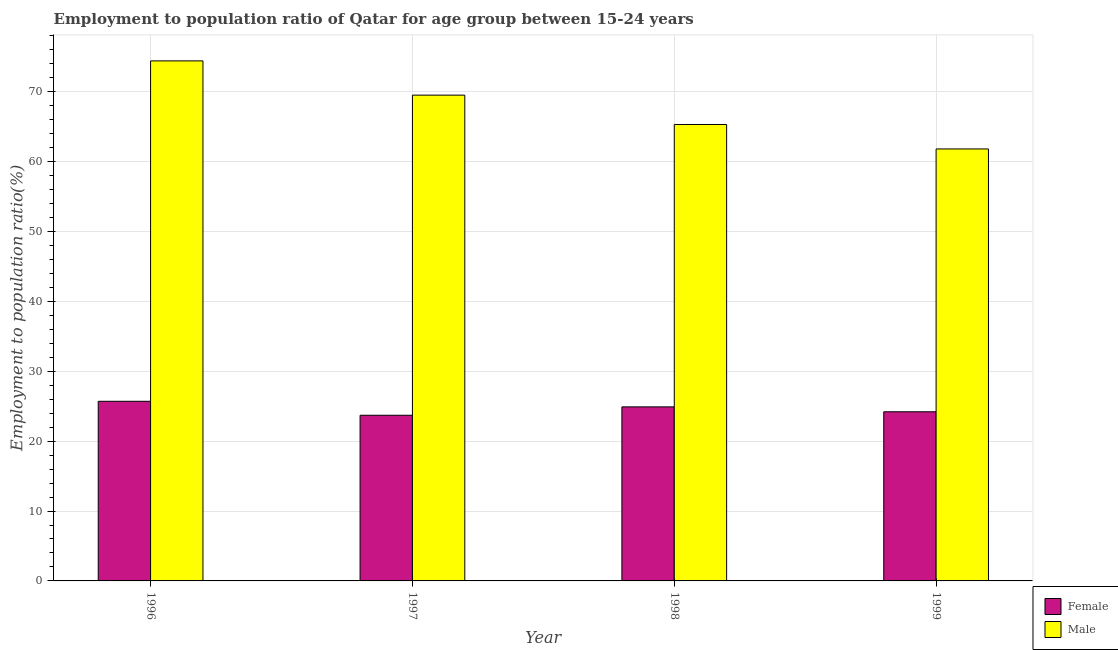How many different coloured bars are there?
Offer a very short reply. 2. Are the number of bars on each tick of the X-axis equal?
Your answer should be compact. Yes. How many bars are there on the 2nd tick from the right?
Offer a terse response. 2. What is the label of the 1st group of bars from the left?
Your answer should be compact. 1996. In how many cases, is the number of bars for a given year not equal to the number of legend labels?
Provide a short and direct response. 0. What is the employment to population ratio(female) in 1999?
Offer a very short reply. 24.2. Across all years, what is the maximum employment to population ratio(male)?
Give a very brief answer. 74.4. Across all years, what is the minimum employment to population ratio(male)?
Keep it short and to the point. 61.8. In which year was the employment to population ratio(female) maximum?
Your answer should be compact. 1996. In which year was the employment to population ratio(female) minimum?
Ensure brevity in your answer.  1997. What is the total employment to population ratio(male) in the graph?
Make the answer very short. 271. What is the difference between the employment to population ratio(female) in 1998 and that in 1999?
Make the answer very short. 0.7. What is the difference between the employment to population ratio(female) in 1998 and the employment to population ratio(male) in 1996?
Ensure brevity in your answer.  -0.8. What is the average employment to population ratio(male) per year?
Your response must be concise. 67.75. What is the ratio of the employment to population ratio(female) in 1996 to that in 1999?
Offer a terse response. 1.06. Is the employment to population ratio(female) in 1996 less than that in 1999?
Offer a very short reply. No. Is the difference between the employment to population ratio(female) in 1998 and 1999 greater than the difference between the employment to population ratio(male) in 1998 and 1999?
Give a very brief answer. No. What is the difference between the highest and the second highest employment to population ratio(female)?
Keep it short and to the point. 0.8. What is the difference between the highest and the lowest employment to population ratio(male)?
Your response must be concise. 12.6. Is the sum of the employment to population ratio(female) in 1997 and 1999 greater than the maximum employment to population ratio(male) across all years?
Keep it short and to the point. Yes. What does the 1st bar from the left in 1998 represents?
Ensure brevity in your answer.  Female. How many bars are there?
Offer a very short reply. 8. How many years are there in the graph?
Offer a very short reply. 4. Does the graph contain any zero values?
Provide a short and direct response. No. Does the graph contain grids?
Your answer should be compact. Yes. What is the title of the graph?
Offer a terse response. Employment to population ratio of Qatar for age group between 15-24 years. Does "Resident workers" appear as one of the legend labels in the graph?
Provide a succinct answer. No. What is the label or title of the X-axis?
Ensure brevity in your answer.  Year. What is the Employment to population ratio(%) of Female in 1996?
Ensure brevity in your answer.  25.7. What is the Employment to population ratio(%) of Male in 1996?
Ensure brevity in your answer.  74.4. What is the Employment to population ratio(%) in Female in 1997?
Offer a very short reply. 23.7. What is the Employment to population ratio(%) of Male in 1997?
Offer a terse response. 69.5. What is the Employment to population ratio(%) in Female in 1998?
Provide a succinct answer. 24.9. What is the Employment to population ratio(%) of Male in 1998?
Make the answer very short. 65.3. What is the Employment to population ratio(%) in Female in 1999?
Provide a succinct answer. 24.2. What is the Employment to population ratio(%) of Male in 1999?
Your response must be concise. 61.8. Across all years, what is the maximum Employment to population ratio(%) in Female?
Keep it short and to the point. 25.7. Across all years, what is the maximum Employment to population ratio(%) of Male?
Offer a very short reply. 74.4. Across all years, what is the minimum Employment to population ratio(%) in Female?
Offer a very short reply. 23.7. Across all years, what is the minimum Employment to population ratio(%) in Male?
Give a very brief answer. 61.8. What is the total Employment to population ratio(%) in Female in the graph?
Make the answer very short. 98.5. What is the total Employment to population ratio(%) of Male in the graph?
Your answer should be compact. 271. What is the difference between the Employment to population ratio(%) of Female in 1996 and that in 1997?
Give a very brief answer. 2. What is the difference between the Employment to population ratio(%) of Male in 1996 and that in 1999?
Give a very brief answer. 12.6. What is the difference between the Employment to population ratio(%) in Female in 1997 and that in 1999?
Provide a short and direct response. -0.5. What is the difference between the Employment to population ratio(%) of Female in 1998 and that in 1999?
Provide a short and direct response. 0.7. What is the difference between the Employment to population ratio(%) in Female in 1996 and the Employment to population ratio(%) in Male in 1997?
Your answer should be very brief. -43.8. What is the difference between the Employment to population ratio(%) of Female in 1996 and the Employment to population ratio(%) of Male in 1998?
Your answer should be very brief. -39.6. What is the difference between the Employment to population ratio(%) in Female in 1996 and the Employment to population ratio(%) in Male in 1999?
Offer a terse response. -36.1. What is the difference between the Employment to population ratio(%) in Female in 1997 and the Employment to population ratio(%) in Male in 1998?
Give a very brief answer. -41.6. What is the difference between the Employment to population ratio(%) in Female in 1997 and the Employment to population ratio(%) in Male in 1999?
Your answer should be compact. -38.1. What is the difference between the Employment to population ratio(%) of Female in 1998 and the Employment to population ratio(%) of Male in 1999?
Keep it short and to the point. -36.9. What is the average Employment to population ratio(%) in Female per year?
Give a very brief answer. 24.62. What is the average Employment to population ratio(%) of Male per year?
Offer a terse response. 67.75. In the year 1996, what is the difference between the Employment to population ratio(%) in Female and Employment to population ratio(%) in Male?
Ensure brevity in your answer.  -48.7. In the year 1997, what is the difference between the Employment to population ratio(%) of Female and Employment to population ratio(%) of Male?
Ensure brevity in your answer.  -45.8. In the year 1998, what is the difference between the Employment to population ratio(%) in Female and Employment to population ratio(%) in Male?
Provide a short and direct response. -40.4. In the year 1999, what is the difference between the Employment to population ratio(%) in Female and Employment to population ratio(%) in Male?
Give a very brief answer. -37.6. What is the ratio of the Employment to population ratio(%) in Female in 1996 to that in 1997?
Provide a succinct answer. 1.08. What is the ratio of the Employment to population ratio(%) in Male in 1996 to that in 1997?
Your answer should be compact. 1.07. What is the ratio of the Employment to population ratio(%) in Female in 1996 to that in 1998?
Your response must be concise. 1.03. What is the ratio of the Employment to population ratio(%) of Male in 1996 to that in 1998?
Provide a short and direct response. 1.14. What is the ratio of the Employment to population ratio(%) of Female in 1996 to that in 1999?
Your answer should be compact. 1.06. What is the ratio of the Employment to population ratio(%) in Male in 1996 to that in 1999?
Provide a succinct answer. 1.2. What is the ratio of the Employment to population ratio(%) in Female in 1997 to that in 1998?
Your answer should be very brief. 0.95. What is the ratio of the Employment to population ratio(%) in Male in 1997 to that in 1998?
Your response must be concise. 1.06. What is the ratio of the Employment to population ratio(%) in Female in 1997 to that in 1999?
Offer a terse response. 0.98. What is the ratio of the Employment to population ratio(%) of Male in 1997 to that in 1999?
Your response must be concise. 1.12. What is the ratio of the Employment to population ratio(%) of Female in 1998 to that in 1999?
Keep it short and to the point. 1.03. What is the ratio of the Employment to population ratio(%) in Male in 1998 to that in 1999?
Make the answer very short. 1.06. What is the difference between the highest and the lowest Employment to population ratio(%) in Female?
Your response must be concise. 2. 